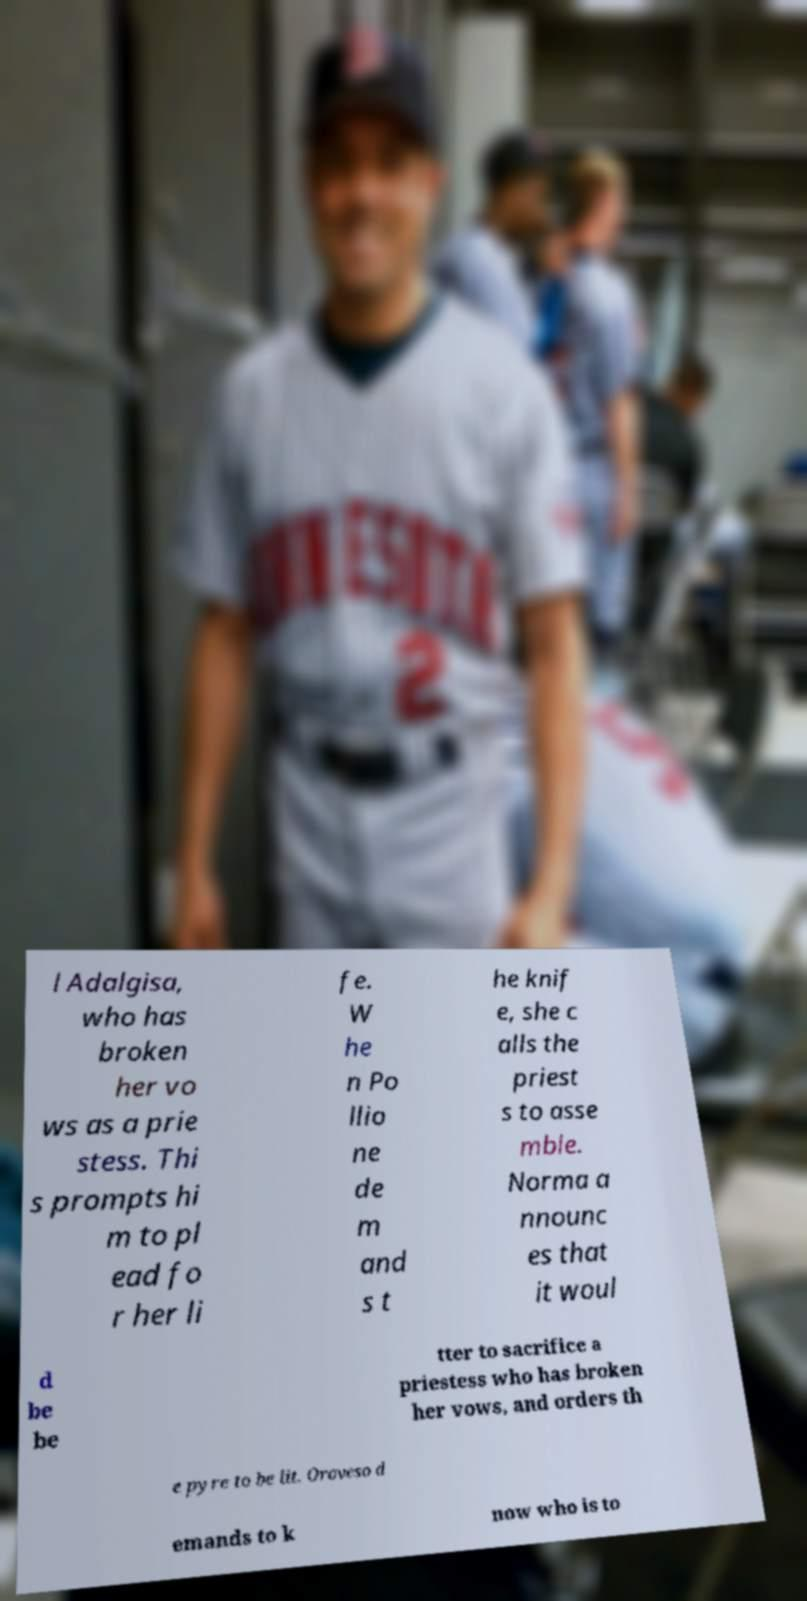Can you accurately transcribe the text from the provided image for me? l Adalgisa, who has broken her vo ws as a prie stess. Thi s prompts hi m to pl ead fo r her li fe. W he n Po llio ne de m and s t he knif e, she c alls the priest s to asse mble. Norma a nnounc es that it woul d be be tter to sacrifice a priestess who has broken her vows, and orders th e pyre to be lit. Oroveso d emands to k now who is to 